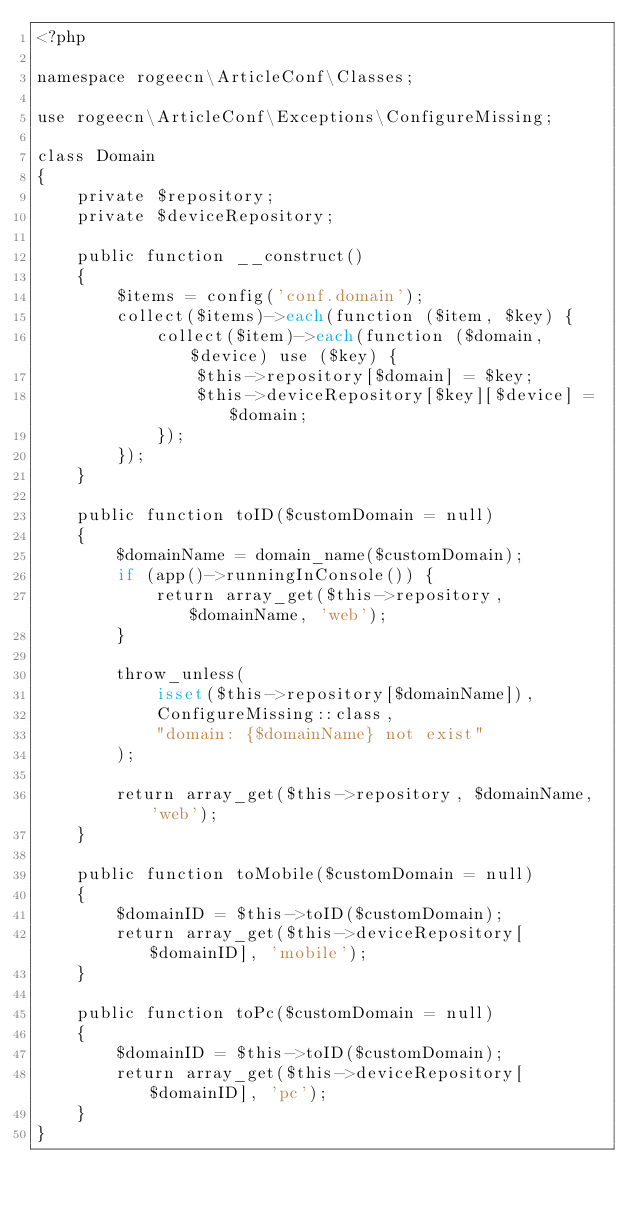<code> <loc_0><loc_0><loc_500><loc_500><_PHP_><?php

namespace rogeecn\ArticleConf\Classes;

use rogeecn\ArticleConf\Exceptions\ConfigureMissing;

class Domain
{
    private $repository;
    private $deviceRepository;

    public function __construct()
    {
        $items = config('conf.domain');
        collect($items)->each(function ($item, $key) {
            collect($item)->each(function ($domain, $device) use ($key) {
                $this->repository[$domain] = $key;
                $this->deviceRepository[$key][$device] = $domain;
            });
        });
    }

    public function toID($customDomain = null)
    {
        $domainName = domain_name($customDomain);
        if (app()->runningInConsole()) {
            return array_get($this->repository, $domainName, 'web');
        }

        throw_unless(
            isset($this->repository[$domainName]),
            ConfigureMissing::class,
            "domain: {$domainName} not exist"
        );

        return array_get($this->repository, $domainName, 'web');
    }

    public function toMobile($customDomain = null)
    {
        $domainID = $this->toID($customDomain);
        return array_get($this->deviceRepository[$domainID], 'mobile');
    }

    public function toPc($customDomain = null)
    {
        $domainID = $this->toID($customDomain);
        return array_get($this->deviceRepository[$domainID], 'pc');
    }
}
</code> 